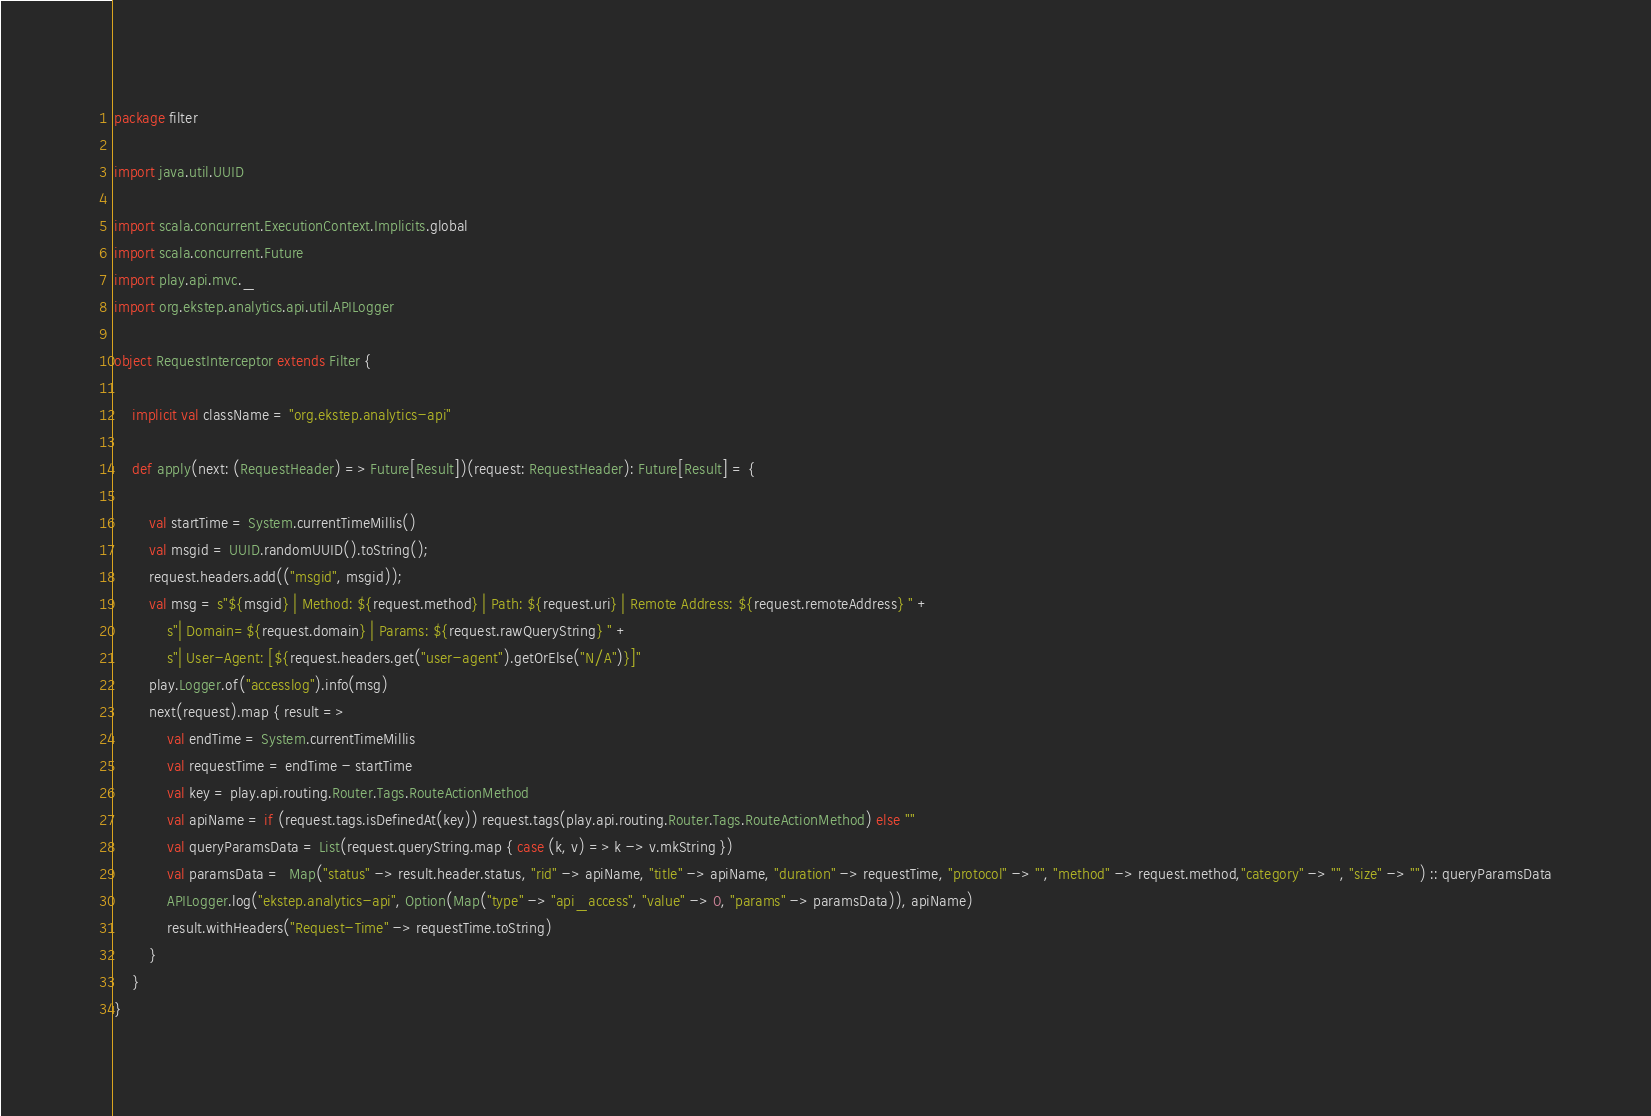<code> <loc_0><loc_0><loc_500><loc_500><_Scala_>package filter

import java.util.UUID

import scala.concurrent.ExecutionContext.Implicits.global
import scala.concurrent.Future
import play.api.mvc._
import org.ekstep.analytics.api.util.APILogger

object RequestInterceptor extends Filter {

    implicit val className = "org.ekstep.analytics-api"

    def apply(next: (RequestHeader) => Future[Result])(request: RequestHeader): Future[Result] = {

        val startTime = System.currentTimeMillis()
        val msgid = UUID.randomUUID().toString();
        request.headers.add(("msgid", msgid));
        val msg = s"${msgid} | Method: ${request.method} | Path: ${request.uri} | Remote Address: ${request.remoteAddress} " +
            s"| Domain=${request.domain} | Params: ${request.rawQueryString} " +
            s"| User-Agent: [${request.headers.get("user-agent").getOrElse("N/A")}]"
        play.Logger.of("accesslog").info(msg)
        next(request).map { result =>
            val endTime = System.currentTimeMillis
            val requestTime = endTime - startTime
            val key = play.api.routing.Router.Tags.RouteActionMethod
            val apiName = if (request.tags.isDefinedAt(key)) request.tags(play.api.routing.Router.Tags.RouteActionMethod) else ""
            val queryParamsData = List(request.queryString.map { case (k, v) => k -> v.mkString })
            val paramsData =  Map("status" -> result.header.status, "rid" -> apiName, "title" -> apiName, "duration" -> requestTime, "protocol" -> "", "method" -> request.method,"category" -> "", "size" -> "") :: queryParamsData
            APILogger.log("ekstep.analytics-api", Option(Map("type" -> "api_access", "value" -> 0, "params" -> paramsData)), apiName)
            result.withHeaders("Request-Time" -> requestTime.toString)
        }
    }
}</code> 